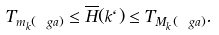Convert formula to latex. <formula><loc_0><loc_0><loc_500><loc_500>T _ { m _ { k } ( \ g a ) } \leq \overline { H } ( k \ell ) \leq T _ { M _ { k } ( \ g a ) } .</formula> 